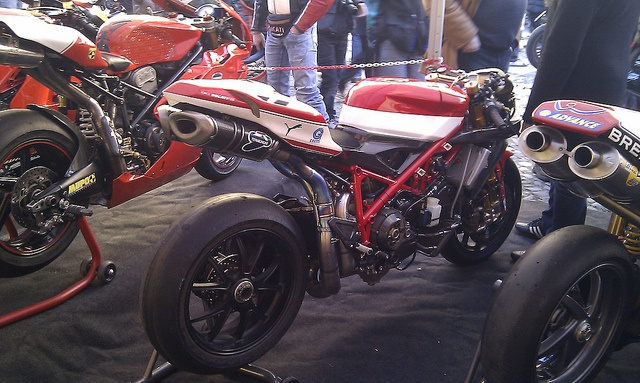Describe the objects in this image and their specific colors. I can see motorcycle in darkgray, black, gray, white, and maroon tones, motorcycle in darkgray, black, gray, white, and maroon tones, motorcycle in darkgray, black, gray, and white tones, people in darkgray, black, and gray tones, and people in darkgray, gray, and lavender tones in this image. 